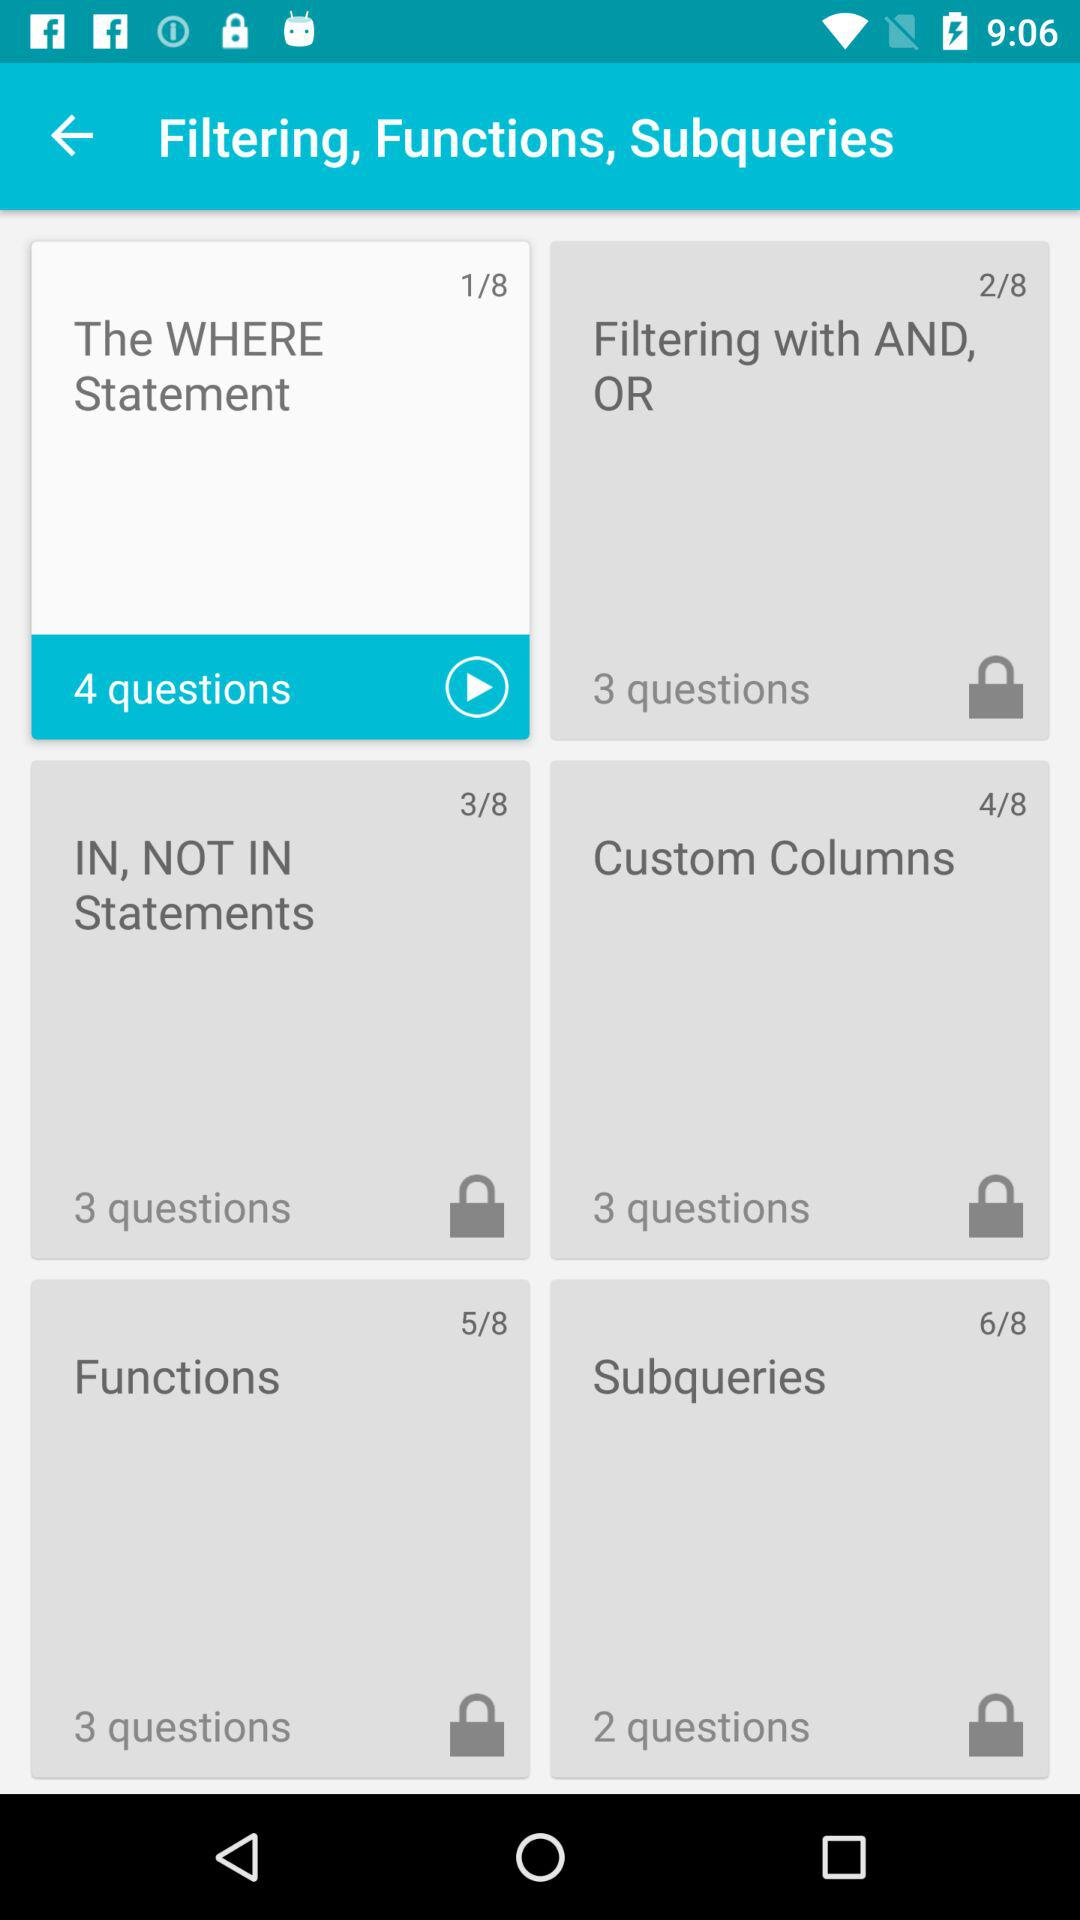What is the slide number for "Custom Columns"? The slide number for "Custom Columns" is 4. 